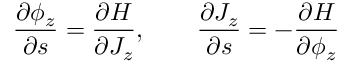<formula> <loc_0><loc_0><loc_500><loc_500>\frac { \partial \phi _ { z } } { \partial s } = \frac { \partial H } { \partial J _ { z } } , \quad \frac { \partial J _ { z } } { \partial s } = - \frac { \partial H } { \partial \phi _ { z } }</formula> 